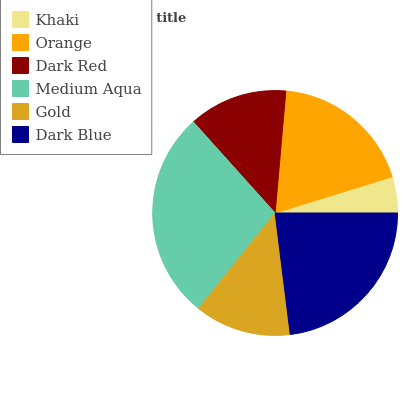Is Khaki the minimum?
Answer yes or no. Yes. Is Medium Aqua the maximum?
Answer yes or no. Yes. Is Orange the minimum?
Answer yes or no. No. Is Orange the maximum?
Answer yes or no. No. Is Orange greater than Khaki?
Answer yes or no. Yes. Is Khaki less than Orange?
Answer yes or no. Yes. Is Khaki greater than Orange?
Answer yes or no. No. Is Orange less than Khaki?
Answer yes or no. No. Is Orange the high median?
Answer yes or no. Yes. Is Dark Red the low median?
Answer yes or no. Yes. Is Dark Blue the high median?
Answer yes or no. No. Is Gold the low median?
Answer yes or no. No. 